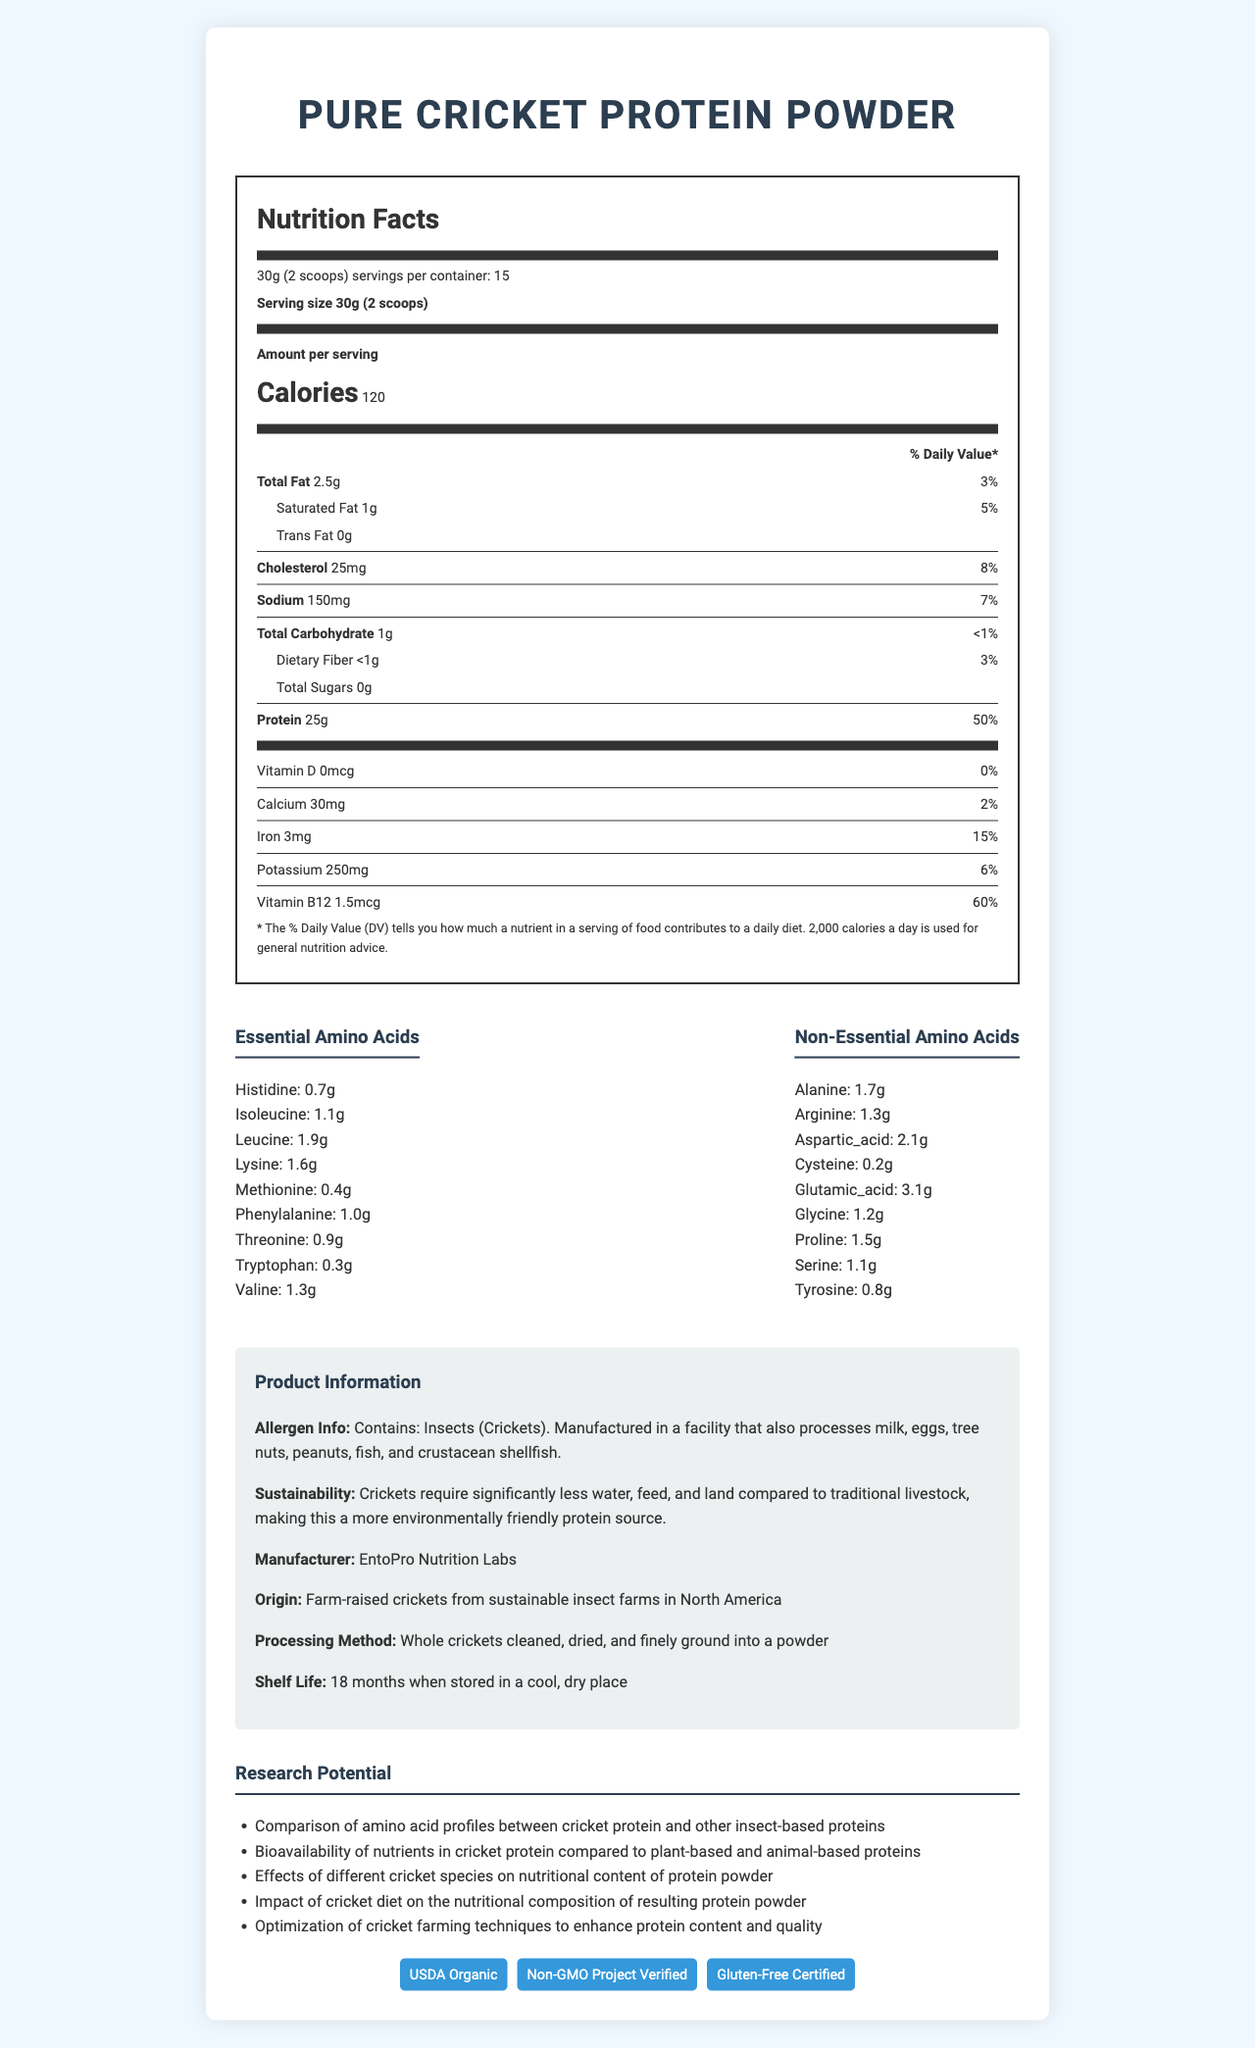what is the serving size of the Pure Cricket Protein Powder? The serving size is clearly mentioned at the top of the nutrition facts label under "Serving size".
Answer: 30g (2 scoops) how many servings are there per container? The number of servings per container is found next to the serving size, stating "15 servings per container".
Answer: 15 how many calories are in one serving of Pure Cricket Protein Powder? The calories per serving are listed prominently under "Amount per serving" in the nutrition facts.
Answer: 120 what is the daily value percentage of protein per serving? The daily value percentage for protein is found next to the protein amount in the nutrition facts.
Answer: 50% which essential amino acid is present in the largest amount? Among the essential amino acids listed, leucine has the largest amount, at 1.9g.
Answer: Leucine which of the following minerals is present in the highest amount per serving? A. Calcium B. Iron C. Potassium According to the nutrition label, Potassium is present at 250mg per serving, which is higher than both calcium and iron.
Answer: C what are the possible allergens mentioned for Pure Cricket Protein Powder? The allergen information is provided under the "Allergen Info" section.
Answer: Insects (Crickets). Manufactured in a facility that also processes milk, eggs, tree nuts, peanuts, fish, and crustacean shellfish. is vitamin D included in Pure Cricket Protein Powder? The nutrition facts state that Vitamin D amount is 0mcg with a 0% daily value, indicating it is not included.
Answer: No are the crickets used in the protein powder farm-raised? The origin section mentions the crickets are farm-raised from sustainable insect farms in North America.
Answer: Yes how does cricket farming compare to traditional livestock in terms of environmental impact? The sustainability info mentions that crickets require significantly less water, feed, and land compared to traditional livestock.
Answer: More environmentally friendly what is the shelf life of Pure Cricket Protein Powder? The shelf life is specifically mentioned at the end of the info section, stating 18 months when stored in a cool, dry place.
Answer: 18 months which certification ensures the product is free from GMOs? A. USDA Organic B. Non-GMO Project Verified C. Gluten-Free Certified The product has multiple certifications, but "Non-GMO Project Verified" indicates it is free from GMOs.
Answer: B does Pure Cricket Protein Powder contain any amounts of trans fat? The nutrition facts clearly list the amount of trans fat as 0g.
Answer: No is Pure Cricket Protein Powder free from sugar? The total sugars amount listed in the nutrition facts is 0g, indicating it is free from sugars.
Answer: Yes what is the main idea of the document? The document encompasses comprehensive details about the nutritional content, environmental benefits, and potential research areas for Pure Cricket Protein Powder, indicating its benefits and suitability for various dietary needs.
Answer: The document provides detailed nutritional information about Pure Cricket Protein Powder, including its serving size, calories, macronutrients, vitamins, minerals, amino acid profile, allergen info, sustainability, research potential, and certifications. what is the main reason why cricket protein is considered sustainable? The document mentions that crickets require less water, feed, and land compared to traditional livestock, but it does not provide detailed environmental data or comparative analysis.
Answer: Not enough information 